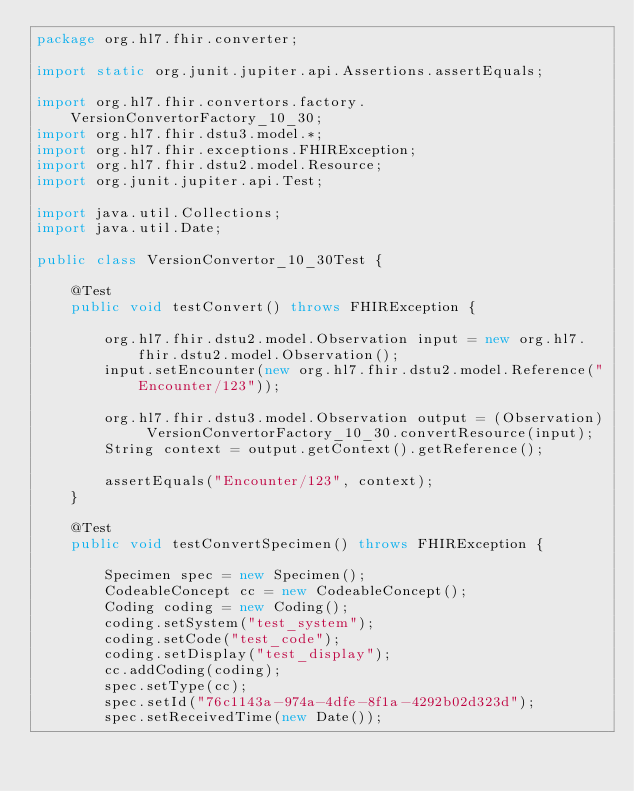<code> <loc_0><loc_0><loc_500><loc_500><_Java_>package org.hl7.fhir.converter;

import static org.junit.jupiter.api.Assertions.assertEquals;

import org.hl7.fhir.convertors.factory.VersionConvertorFactory_10_30;
import org.hl7.fhir.dstu3.model.*;
import org.hl7.fhir.exceptions.FHIRException;
import org.hl7.fhir.dstu2.model.Resource;
import org.junit.jupiter.api.Test;

import java.util.Collections;
import java.util.Date;

public class VersionConvertor_10_30Test {

	@Test
	public void testConvert() throws FHIRException {
		
		org.hl7.fhir.dstu2.model.Observation input = new org.hl7.fhir.dstu2.model.Observation();
		input.setEncounter(new org.hl7.fhir.dstu2.model.Reference("Encounter/123"));
		
		org.hl7.fhir.dstu3.model.Observation output = (Observation) VersionConvertorFactory_10_30.convertResource(input);
		String context = output.getContext().getReference();
		
		assertEquals("Encounter/123", context);
	}

	@Test
	public void testConvertSpecimen() throws FHIRException {

		Specimen spec = new Specimen();
		CodeableConcept cc = new CodeableConcept();
		Coding coding = new Coding();
		coding.setSystem("test_system");
		coding.setCode("test_code");
		coding.setDisplay("test_display");
		cc.addCoding(coding);
		spec.setType(cc);
		spec.setId("76c1143a-974a-4dfe-8f1a-4292b02d323d");
		spec.setReceivedTime(new Date());</code> 